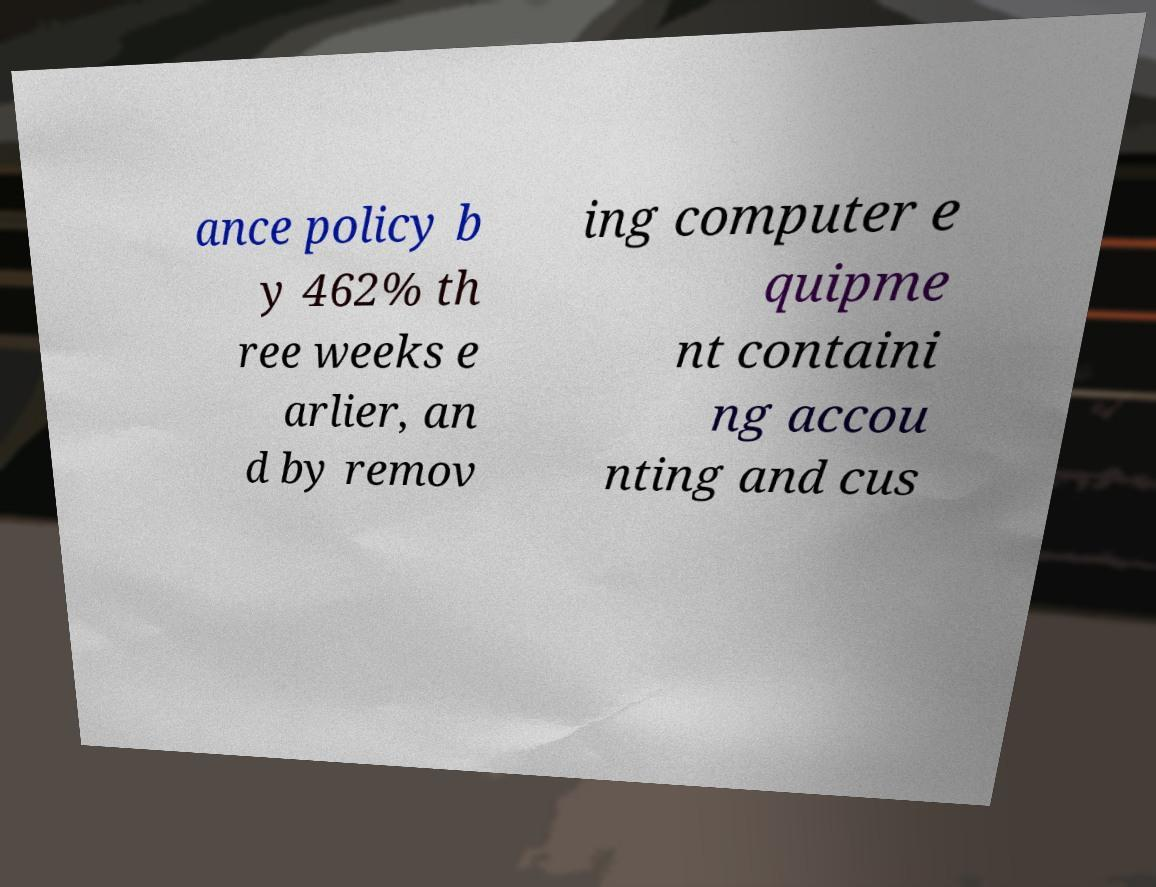Please read and relay the text visible in this image. What does it say? ance policy b y 462% th ree weeks e arlier, an d by remov ing computer e quipme nt containi ng accou nting and cus 